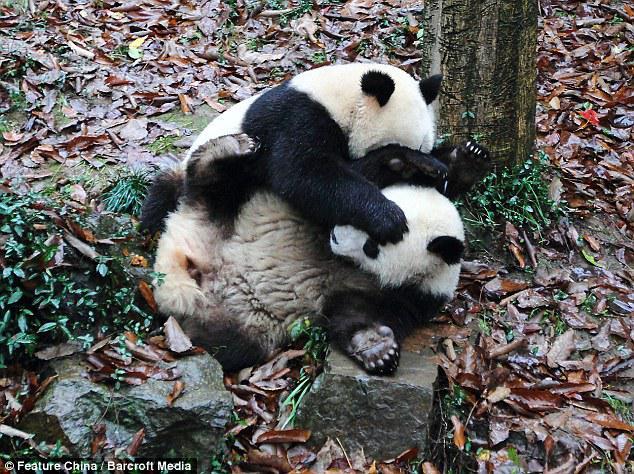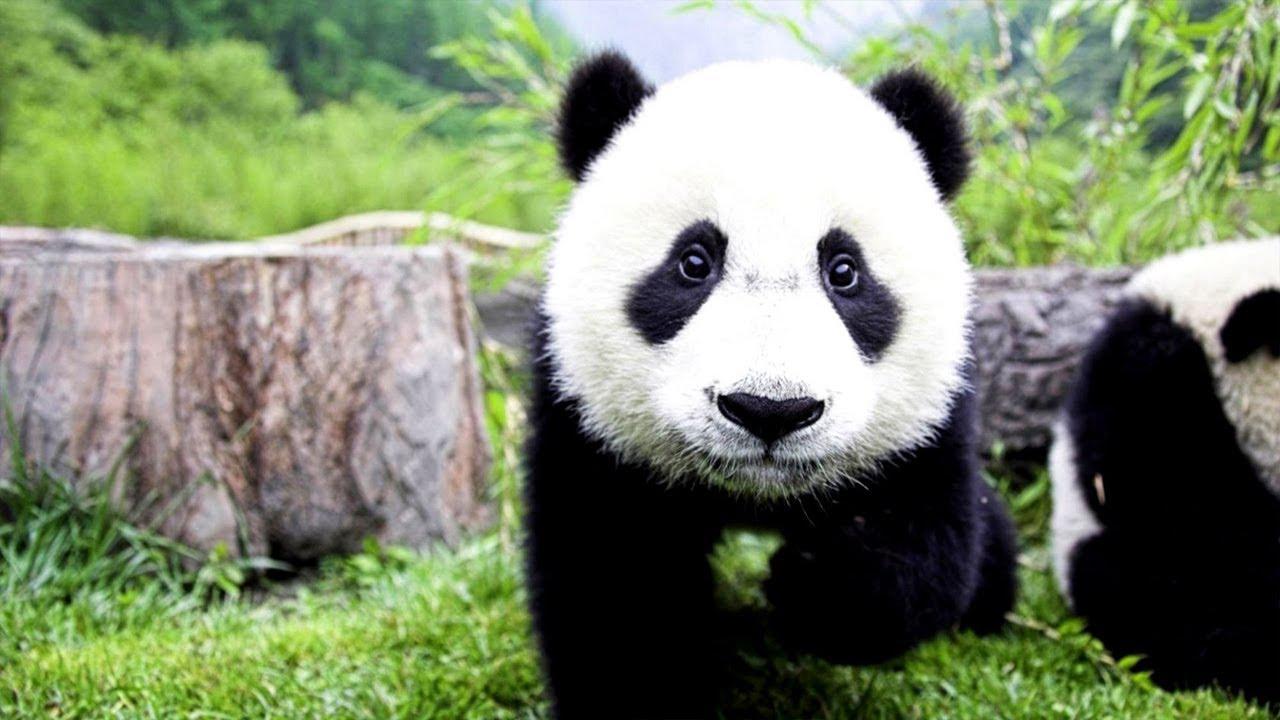The first image is the image on the left, the second image is the image on the right. Considering the images on both sides, is "One panda is looking straight ahead." valid? Answer yes or no. Yes. The first image is the image on the left, the second image is the image on the right. For the images shown, is this caption "there are two pandas in front of a tree trunk" true? Answer yes or no. Yes. 